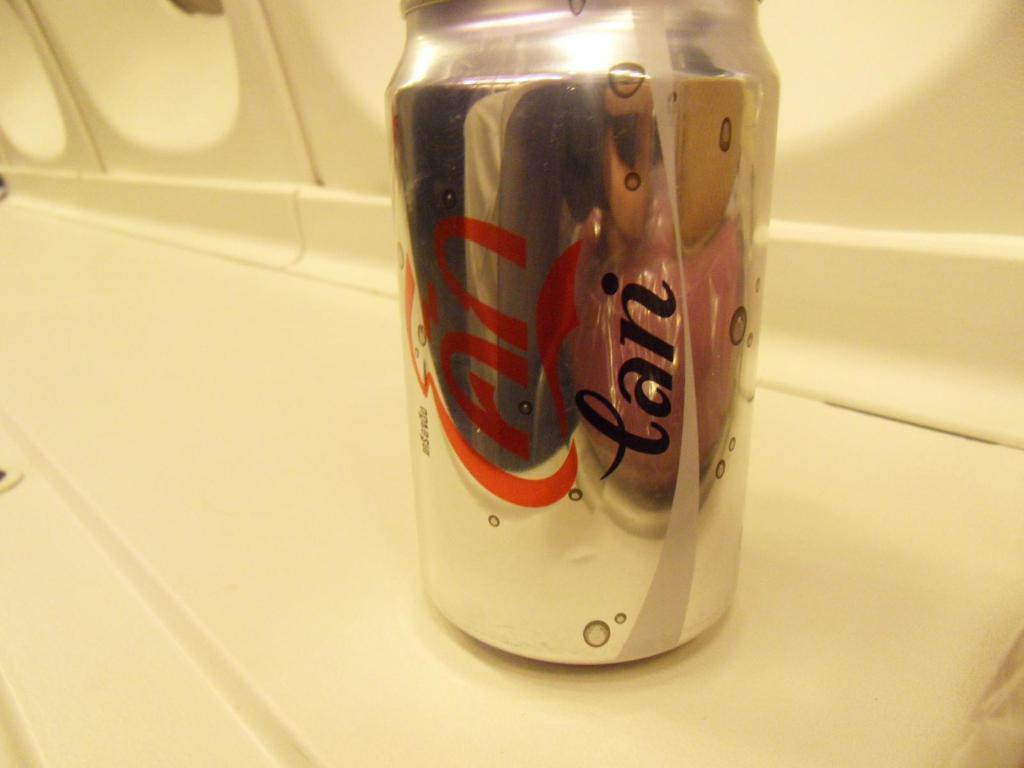Who's name is on the can?
Offer a terse response. Ian. 